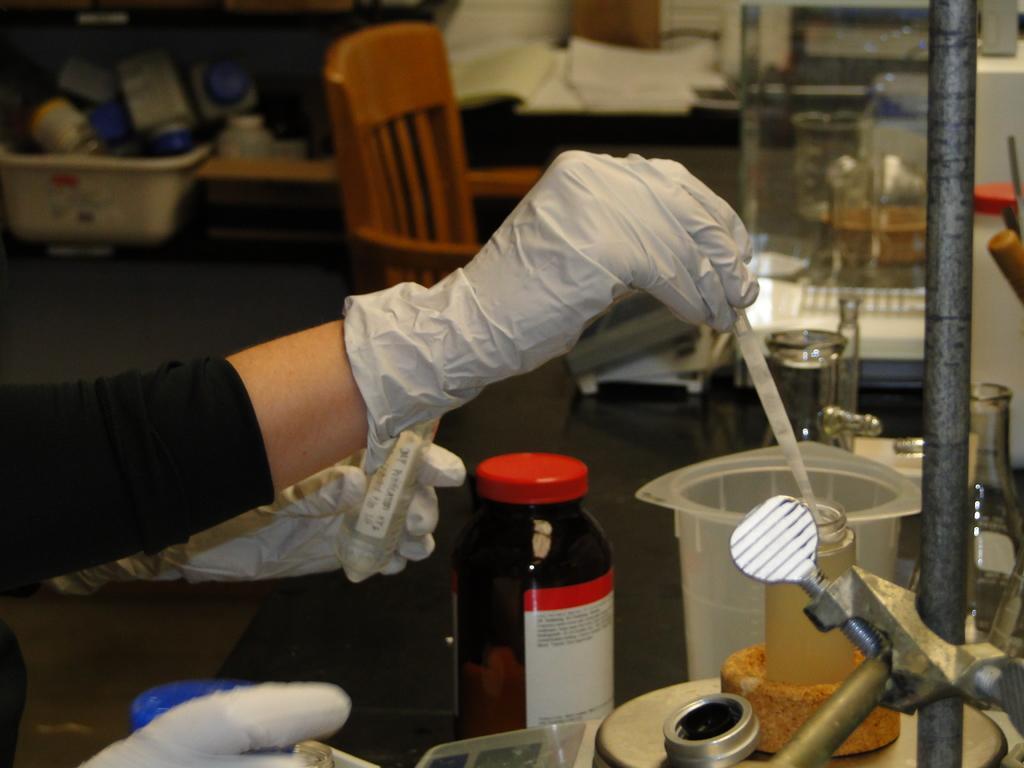In one or two sentences, can you explain what this image depicts? In the middle a person's hand visible who is wearing a gloves in his hand and preparing chemical solutions in the bottle and jar. On the right a rod is visible. In the top chairs, boxes, jars and cupboards are visible and books are there. This image is taken inside a lab. 